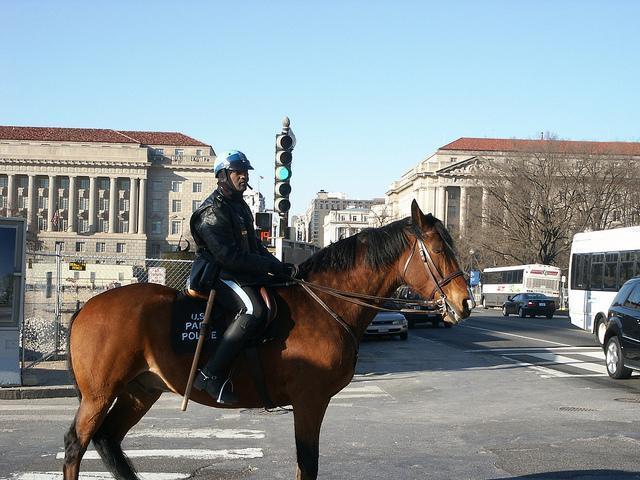Why is he on a horse?
Choose the right answer and clarify with the format: 'Answer: answer
Rationale: rationale.'
Options: Stole horse, showing off, can't walk, is patrolling. Answer: is patrolling.
Rationale: This is a police man that is riding around and protecting the city. 